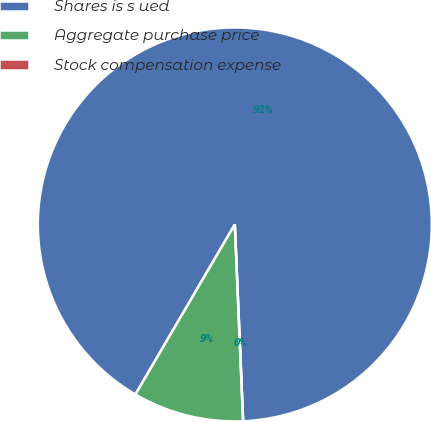Convert chart. <chart><loc_0><loc_0><loc_500><loc_500><pie_chart><fcel>Shares is s ued<fcel>Aggregate purchase price<fcel>Stock compensation expense<nl><fcel>90.91%<fcel>9.09%<fcel>0.0%<nl></chart> 